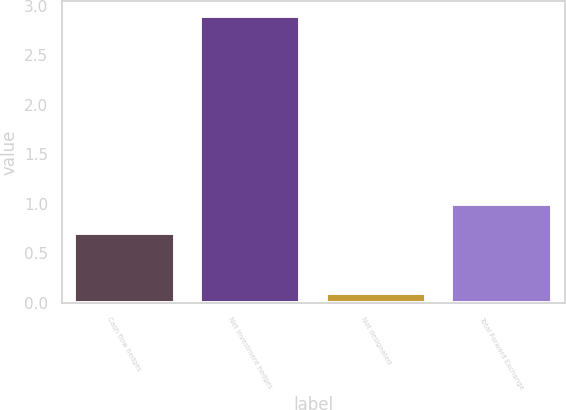<chart> <loc_0><loc_0><loc_500><loc_500><bar_chart><fcel>Cash flow hedges<fcel>Net investment hedges<fcel>Not designated<fcel>Total Forward Exchange<nl><fcel>0.7<fcel>2.9<fcel>0.1<fcel>1<nl></chart> 